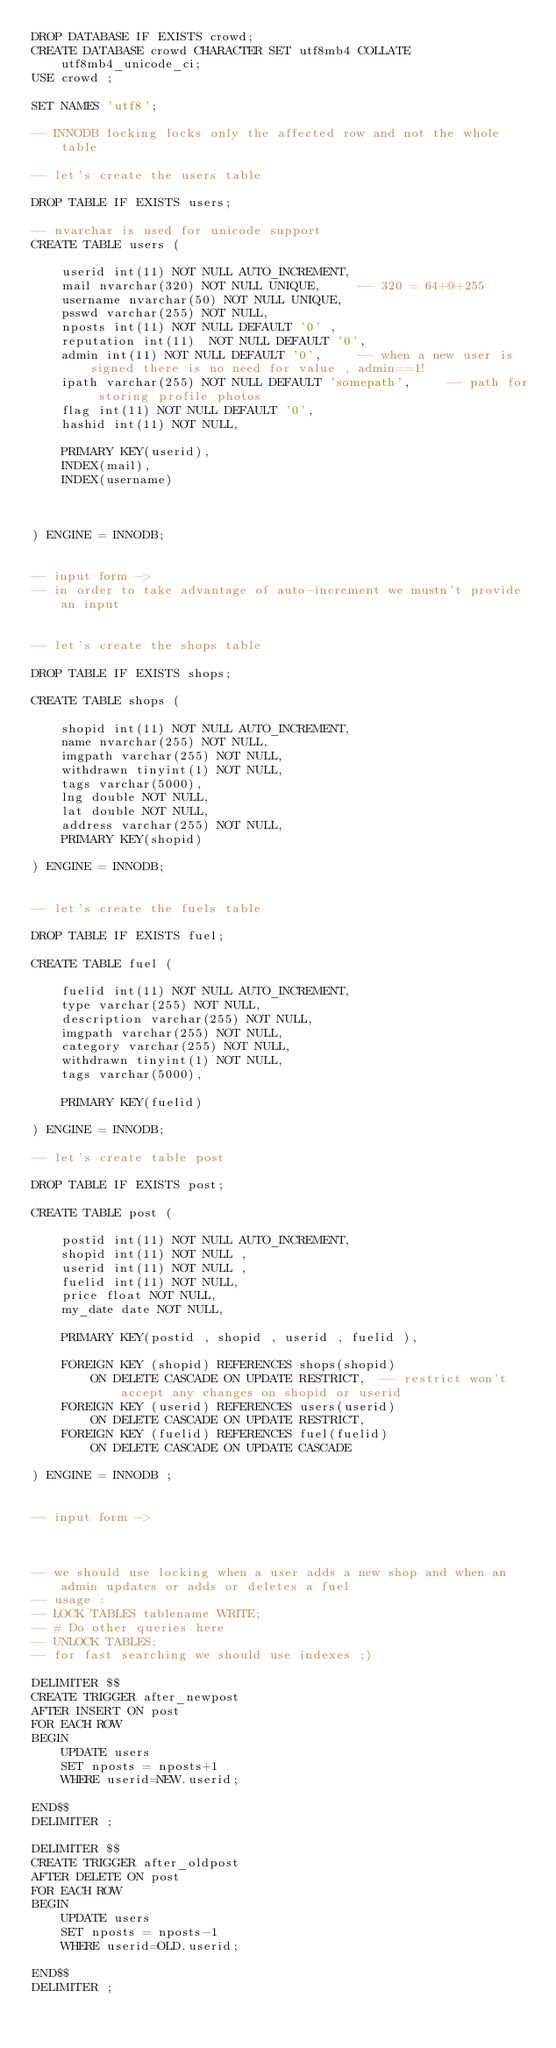Convert code to text. <code><loc_0><loc_0><loc_500><loc_500><_SQL_>DROP DATABASE IF EXISTS crowd;
CREATE DATABASE crowd CHARACTER SET utf8mb4 COLLATE utf8mb4_unicode_ci;
USE crowd ;

SET NAMES 'utf8';

-- INNODB locking locks only the affected row and not the whole table

-- let's create the users table

DROP TABLE IF EXISTS users;

-- nvarchar is used for unicode support
CREATE TABLE users (

    userid int(11) NOT NULL AUTO_INCREMENT,
    mail nvarchar(320) NOT NULL UNIQUE,     -- 320 = 64+@+255
    username nvarchar(50) NOT NULL UNIQUE,
    psswd varchar(255) NOT NULL,
    nposts int(11) NOT NULL DEFAULT '0' ,
    reputation int(11)  NOT NULL DEFAULT '0',
    admin int(11) NOT NULL DEFAULT '0',     -- when a new user is signed there is no need for value , admin==1!
    ipath varchar(255) NOT NULL DEFAULT 'somepath',     -- path for storing profile photos
    flag int(11) NOT NULL DEFAULT '0',
    hashid int(11) NOT NULL,

    PRIMARY KEY(userid),
    INDEX(mail),
    INDEX(username)



) ENGINE = INNODB;


-- input form ->
-- in order to take advantage of auto-increment we mustn't provide an input


-- let's create the shops table

DROP TABLE IF EXISTS shops;

CREATE TABLE shops (

    shopid int(11) NOT NULL AUTO_INCREMENT,
    name nvarchar(255) NOT NULL,
    imgpath varchar(255) NOT NULL,
    withdrawn tinyint(1) NOT NULL,
    tags varchar(5000),
    lng double NOT NULL,
    lat double NOT NULL,
    address varchar(255) NOT NULL,
    PRIMARY KEY(shopid)

) ENGINE = INNODB;


-- let's create the fuels table

DROP TABLE IF EXISTS fuel;

CREATE TABLE fuel (

    fuelid int(11) NOT NULL AUTO_INCREMENT,
    type varchar(255) NOT NULL,
    description varchar(255) NOT NULL,
    imgpath varchar(255) NOT NULL,
    category varchar(255) NOT NULL,
    withdrawn tinyint(1) NOT NULL,
    tags varchar(5000),

    PRIMARY KEY(fuelid)

) ENGINE = INNODB;

-- let's create table post

DROP TABLE IF EXISTS post;

CREATE TABLE post (

    postid int(11) NOT NULL AUTO_INCREMENT,
    shopid int(11) NOT NULL ,
    userid int(11) NOT NULL ,
    fuelid int(11) NOT NULL,
    price float NOT NULL,
    my_date date NOT NULL,

    PRIMARY KEY(postid , shopid , userid , fuelid ),

    FOREIGN KEY (shopid) REFERENCES shops(shopid)
        ON DELETE CASCADE ON UPDATE RESTRICT,  -- restrict won't accept any changes on shopid or userid
    FOREIGN KEY (userid) REFERENCES users(userid)
        ON DELETE CASCADE ON UPDATE RESTRICT,
    FOREIGN KEY (fuelid) REFERENCES fuel(fuelid)
        ON DELETE CASCADE ON UPDATE CASCADE

) ENGINE = INNODB ;


-- input form ->



-- we should use locking when a user adds a new shop and when an admin updates or adds or deletes a fuel
-- usage :
-- LOCK TABLES tablename WRITE;
-- # Do other queries here
-- UNLOCK TABLES;
-- for fast searching we should use indexes ;)

DELIMITER $$
CREATE TRIGGER after_newpost
AFTER INSERT ON post
FOR EACH ROW
BEGIN
    UPDATE users
    SET nposts = nposts+1
    WHERE userid=NEW.userid;

END$$
DELIMITER ;

DELIMITER $$
CREATE TRIGGER after_oldpost
AFTER DELETE ON post
FOR EACH ROW
BEGIN
    UPDATE users
    SET nposts = nposts-1
    WHERE userid=OLD.userid;

END$$
DELIMITER ;
</code> 